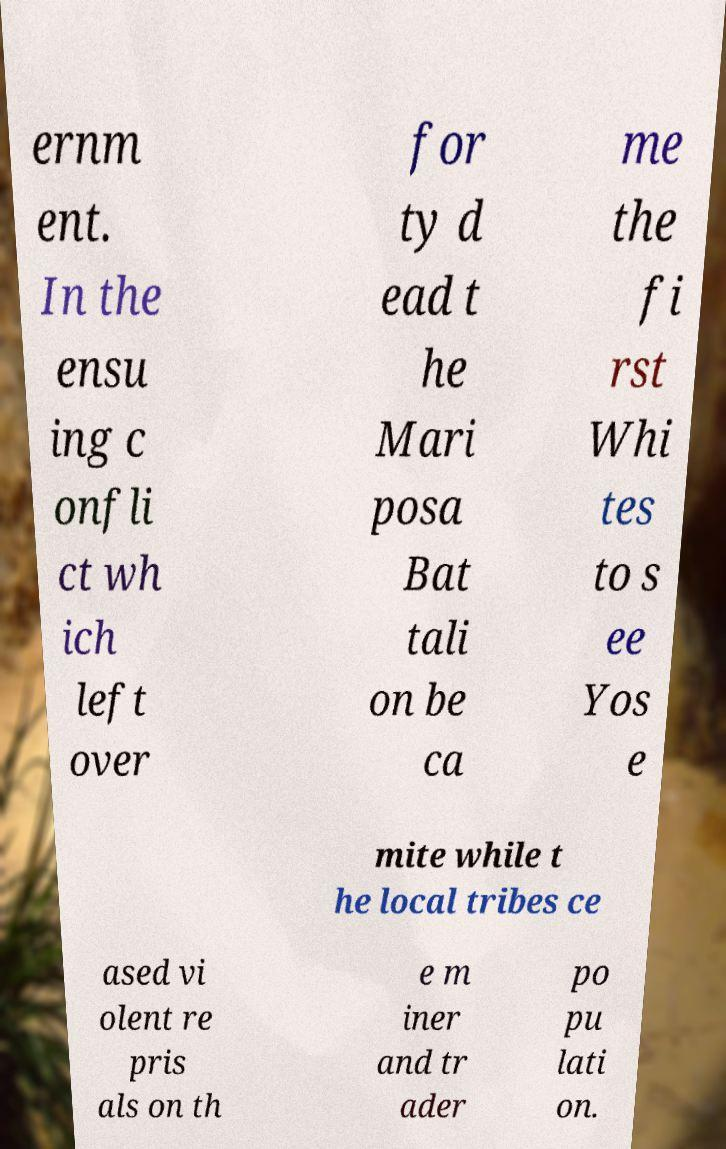Can you accurately transcribe the text from the provided image for me? ernm ent. In the ensu ing c onfli ct wh ich left over for ty d ead t he Mari posa Bat tali on be ca me the fi rst Whi tes to s ee Yos e mite while t he local tribes ce ased vi olent re pris als on th e m iner and tr ader po pu lati on. 